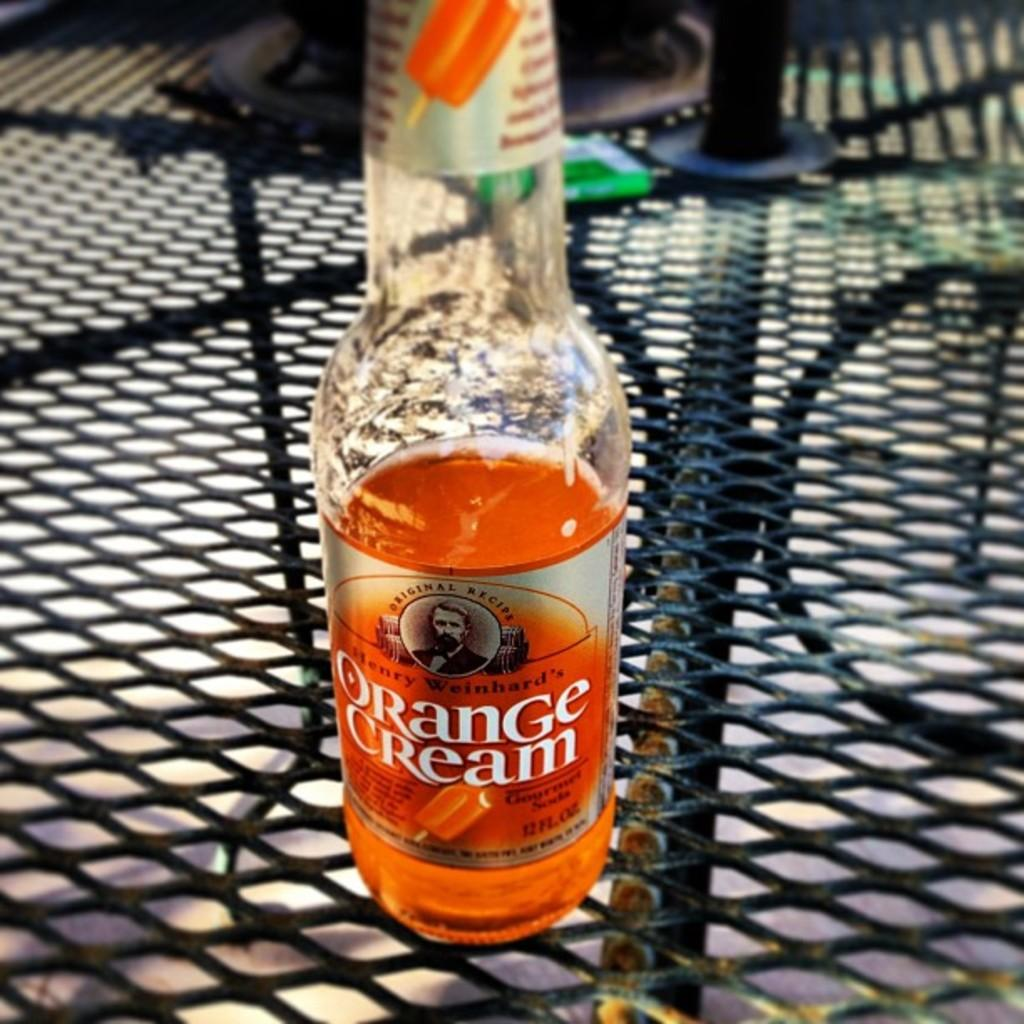<image>
Write a terse but informative summary of the picture. Orange Cream beer on top of a table outdoors. 